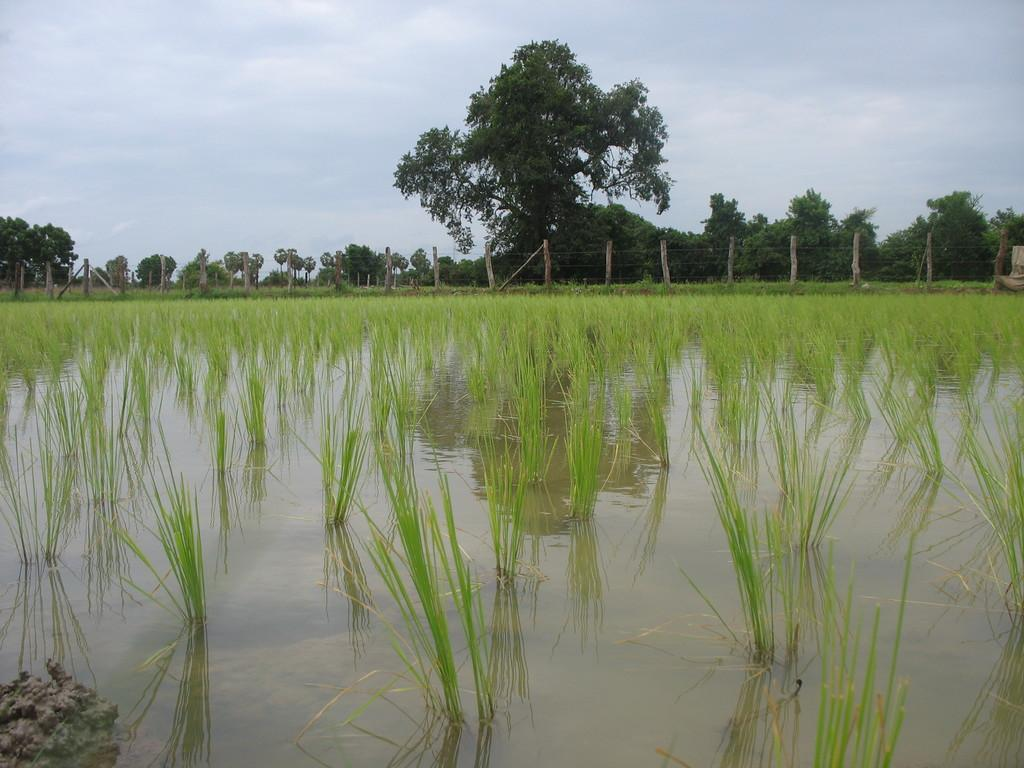What type of environment is depicted in the image? The image shows plants on land with water. What is located behind the plants? There is a fence behind the plants. What is visible beyond the fence? There are trees behind the fence. What can be seen at the top of the image? The sky is visible at the top of the image. Are there any fairies visible in the image? There are no fairies present in the image. What type of yard is shown in the image? The image does not show a yard; it depicts plants on land with water, a fence, trees, and the sky. 